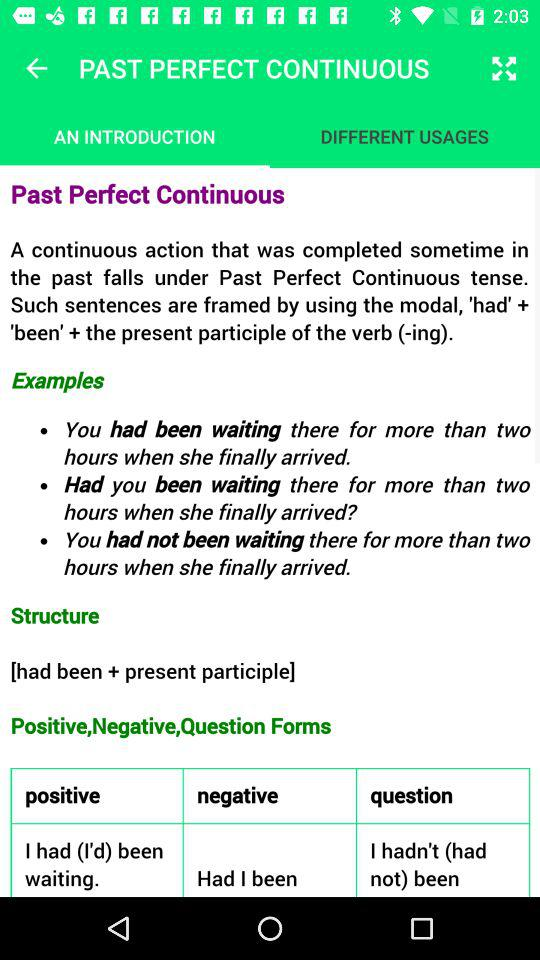Which tab am I using? You are using the "AN INTRODUCTION" tab. 